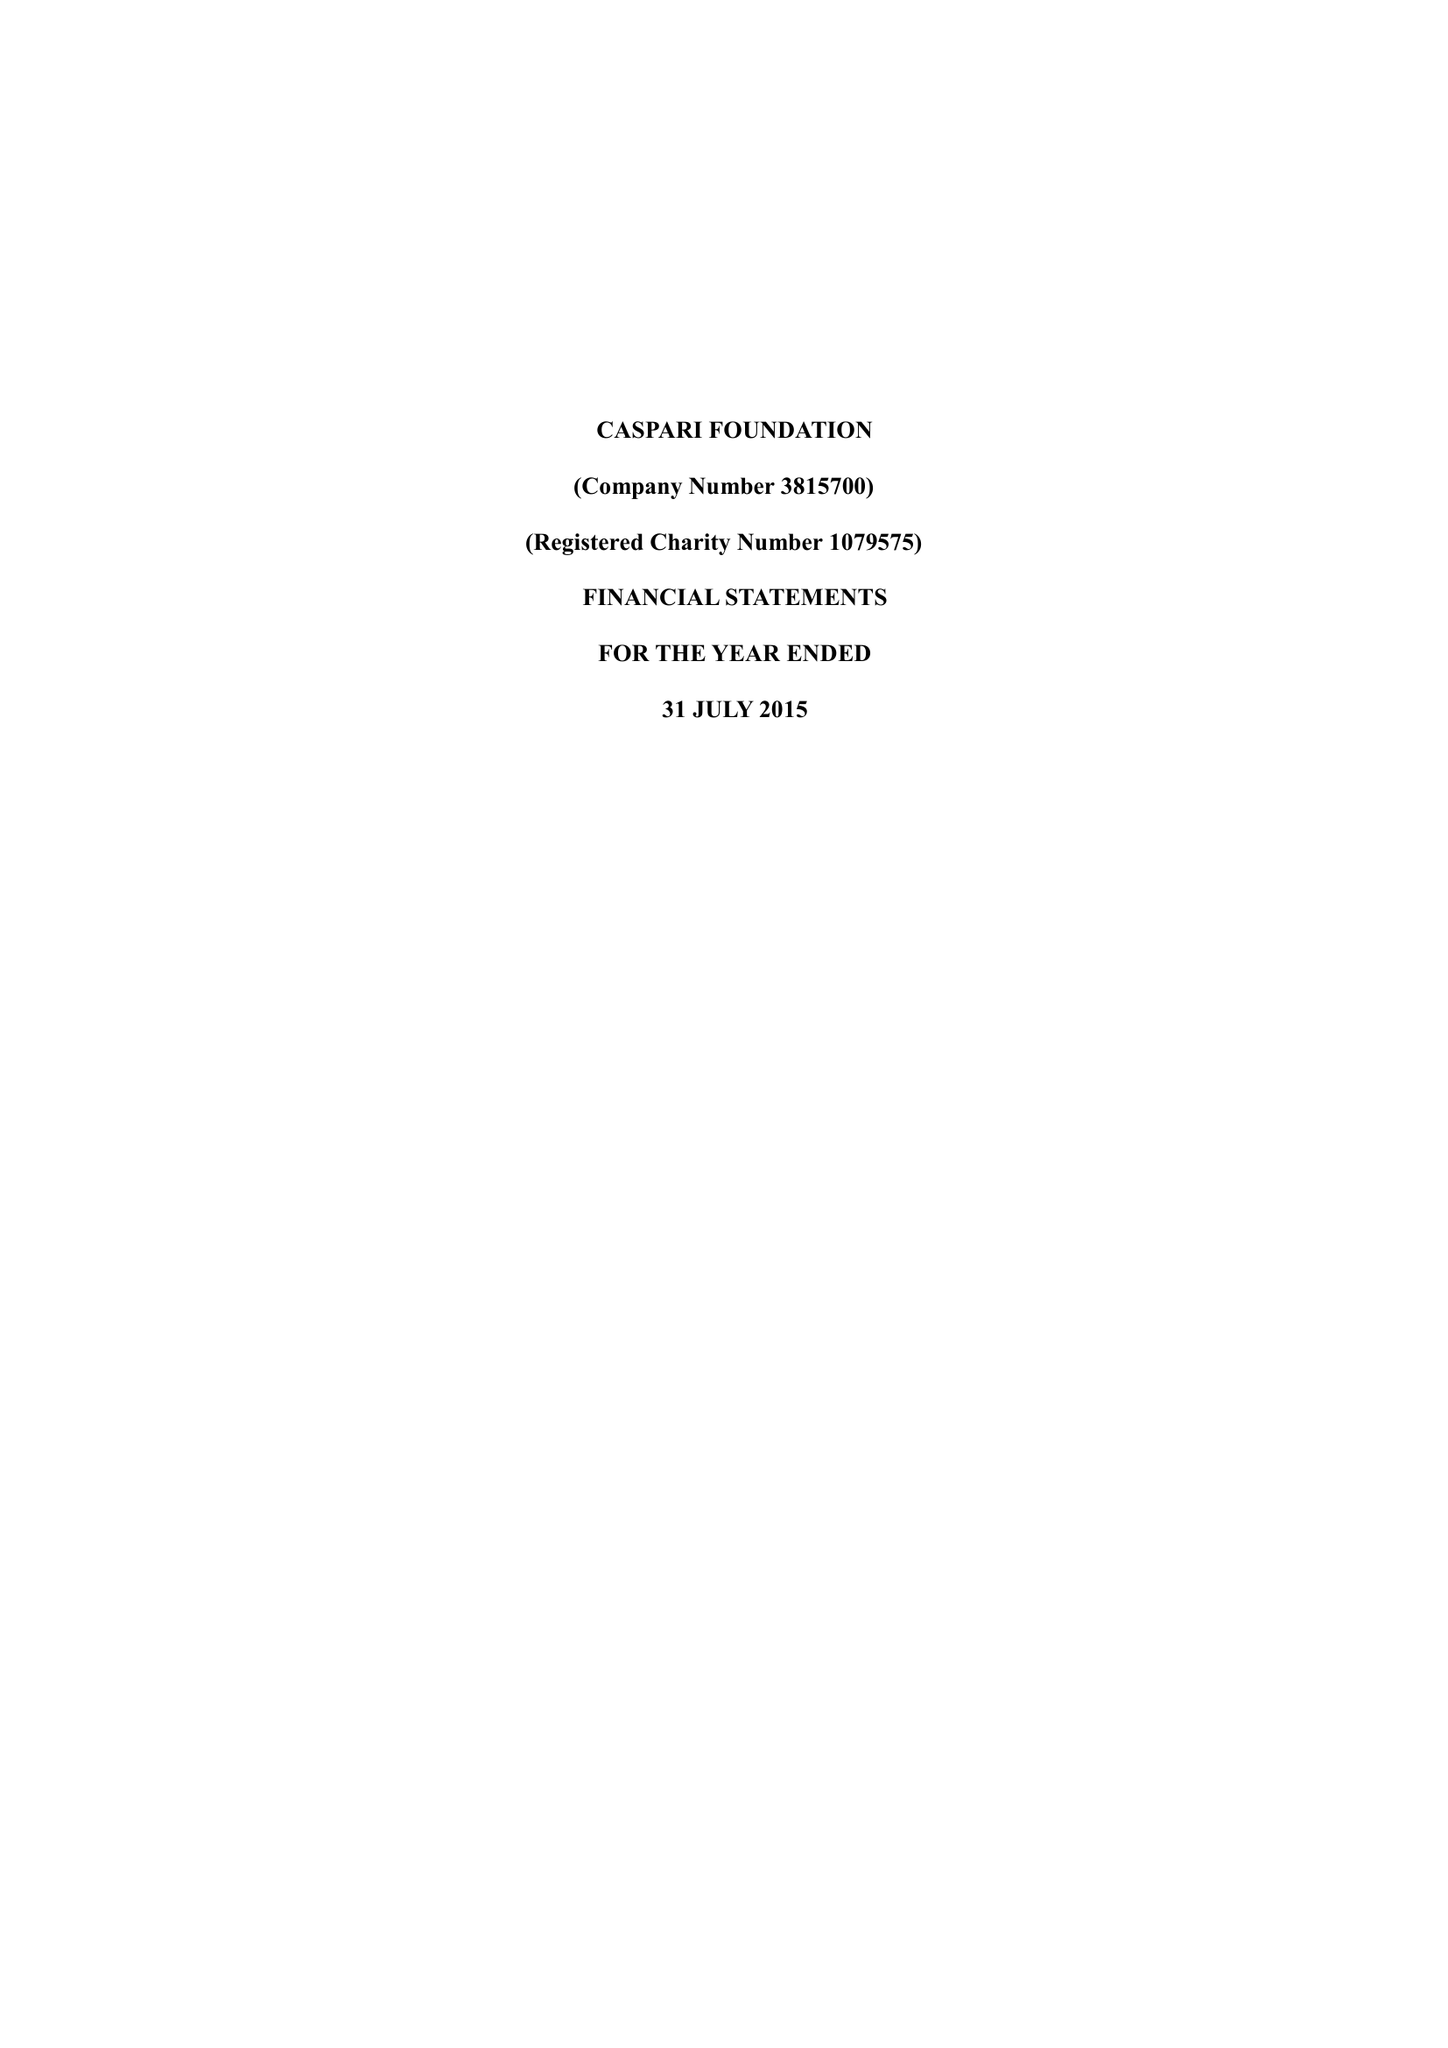What is the value for the report_date?
Answer the question using a single word or phrase. 2015-07-31 